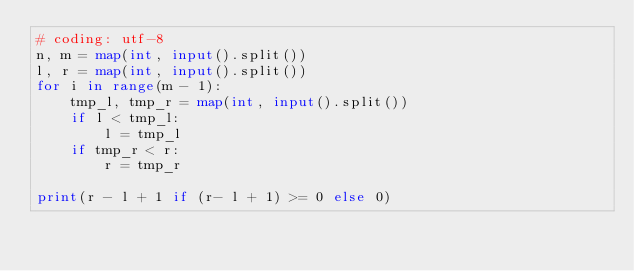<code> <loc_0><loc_0><loc_500><loc_500><_Python_># coding: utf-8
n, m = map(int, input().split())
l, r = map(int, input().split())
for i in range(m - 1):
    tmp_l, tmp_r = map(int, input().split())
    if l < tmp_l:
        l = tmp_l
    if tmp_r < r:
        r = tmp_r

print(r - l + 1 if (r- l + 1) >= 0 else 0)
</code> 